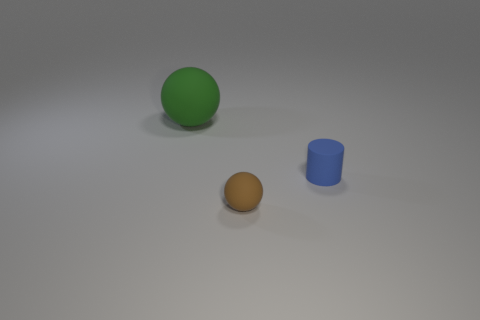Add 1 large blue metallic cylinders. How many objects exist? 4 Subtract all green spheres. How many spheres are left? 1 Subtract all spheres. How many objects are left? 1 Add 2 small blue matte things. How many small blue matte things are left? 3 Add 2 big cyan matte balls. How many big cyan matte balls exist? 2 Subtract 1 brown spheres. How many objects are left? 2 Subtract all cylinders. Subtract all big things. How many objects are left? 1 